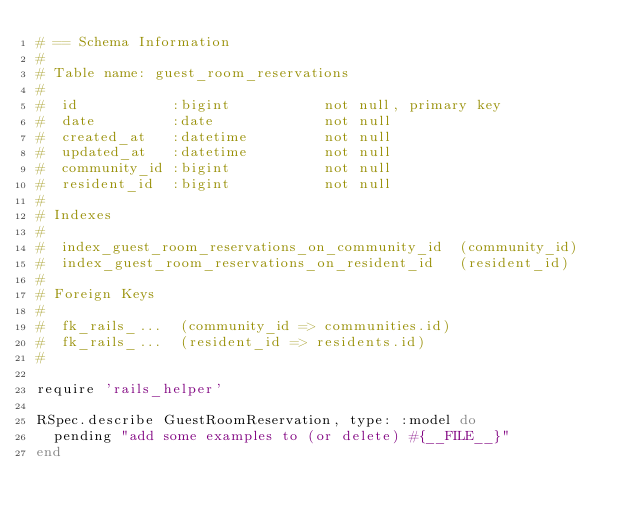<code> <loc_0><loc_0><loc_500><loc_500><_Ruby_># == Schema Information
#
# Table name: guest_room_reservations
#
#  id           :bigint           not null, primary key
#  date         :date             not null
#  created_at   :datetime         not null
#  updated_at   :datetime         not null
#  community_id :bigint           not null
#  resident_id  :bigint           not null
#
# Indexes
#
#  index_guest_room_reservations_on_community_id  (community_id)
#  index_guest_room_reservations_on_resident_id   (resident_id)
#
# Foreign Keys
#
#  fk_rails_...  (community_id => communities.id)
#  fk_rails_...  (resident_id => residents.id)
#

require 'rails_helper'

RSpec.describe GuestRoomReservation, type: :model do
  pending "add some examples to (or delete) #{__FILE__}"
end
</code> 